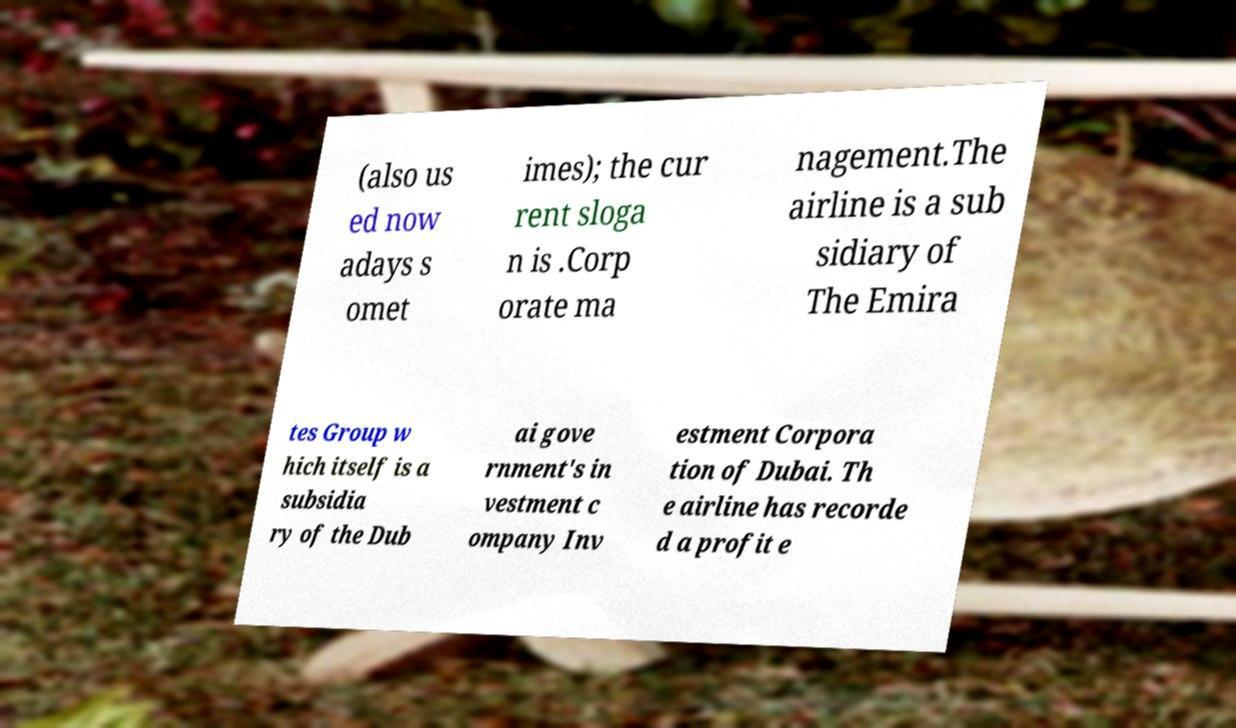Could you extract and type out the text from this image? (also us ed now adays s omet imes); the cur rent sloga n is .Corp orate ma nagement.The airline is a sub sidiary of The Emira tes Group w hich itself is a subsidia ry of the Dub ai gove rnment's in vestment c ompany Inv estment Corpora tion of Dubai. Th e airline has recorde d a profit e 